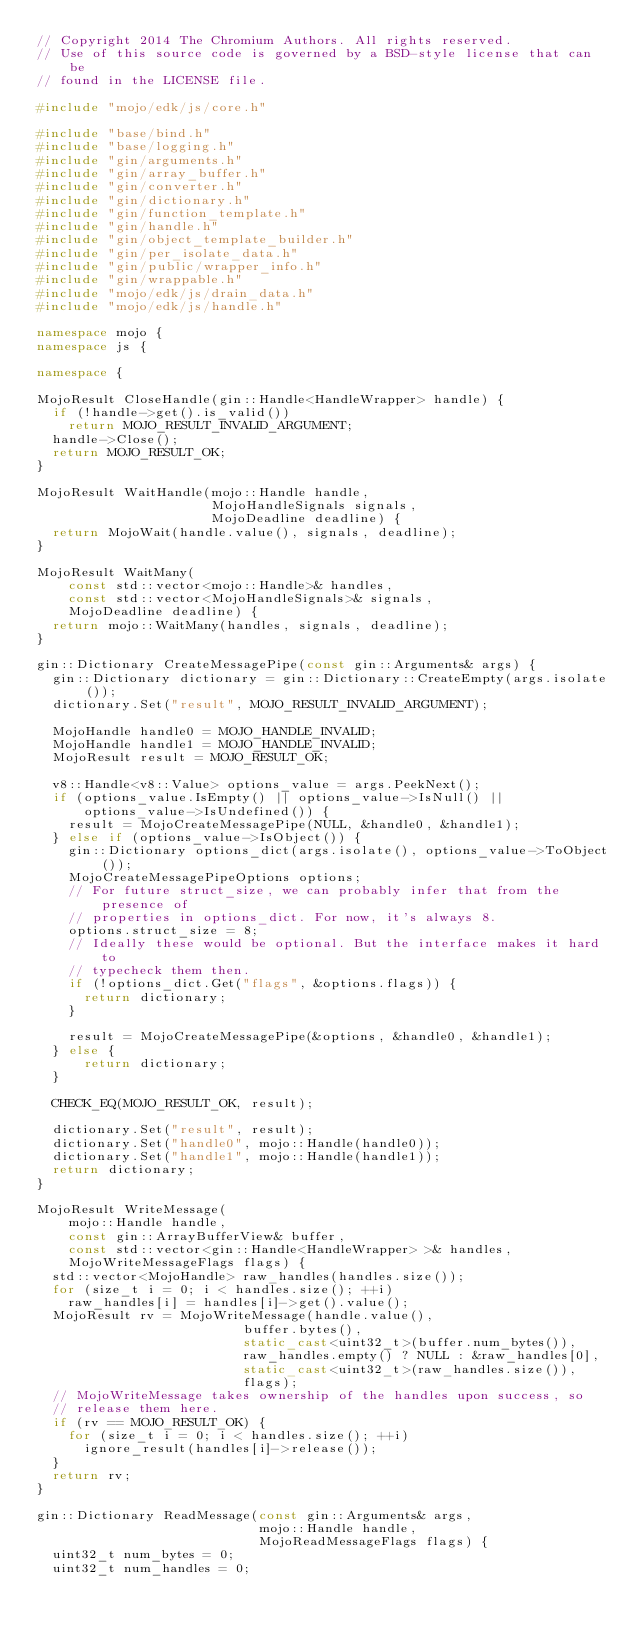<code> <loc_0><loc_0><loc_500><loc_500><_C++_>// Copyright 2014 The Chromium Authors. All rights reserved.
// Use of this source code is governed by a BSD-style license that can be
// found in the LICENSE file.

#include "mojo/edk/js/core.h"

#include "base/bind.h"
#include "base/logging.h"
#include "gin/arguments.h"
#include "gin/array_buffer.h"
#include "gin/converter.h"
#include "gin/dictionary.h"
#include "gin/function_template.h"
#include "gin/handle.h"
#include "gin/object_template_builder.h"
#include "gin/per_isolate_data.h"
#include "gin/public/wrapper_info.h"
#include "gin/wrappable.h"
#include "mojo/edk/js/drain_data.h"
#include "mojo/edk/js/handle.h"

namespace mojo {
namespace js {

namespace {

MojoResult CloseHandle(gin::Handle<HandleWrapper> handle) {
  if (!handle->get().is_valid())
    return MOJO_RESULT_INVALID_ARGUMENT;
  handle->Close();
  return MOJO_RESULT_OK;
}

MojoResult WaitHandle(mojo::Handle handle,
                      MojoHandleSignals signals,
                      MojoDeadline deadline) {
  return MojoWait(handle.value(), signals, deadline);
}

MojoResult WaitMany(
    const std::vector<mojo::Handle>& handles,
    const std::vector<MojoHandleSignals>& signals,
    MojoDeadline deadline) {
  return mojo::WaitMany(handles, signals, deadline);
}

gin::Dictionary CreateMessagePipe(const gin::Arguments& args) {
  gin::Dictionary dictionary = gin::Dictionary::CreateEmpty(args.isolate());
  dictionary.Set("result", MOJO_RESULT_INVALID_ARGUMENT);

  MojoHandle handle0 = MOJO_HANDLE_INVALID;
  MojoHandle handle1 = MOJO_HANDLE_INVALID;
  MojoResult result = MOJO_RESULT_OK;

  v8::Handle<v8::Value> options_value = args.PeekNext();
  if (options_value.IsEmpty() || options_value->IsNull() ||
      options_value->IsUndefined()) {
    result = MojoCreateMessagePipe(NULL, &handle0, &handle1);
  } else if (options_value->IsObject()) {
    gin::Dictionary options_dict(args.isolate(), options_value->ToObject());
    MojoCreateMessagePipeOptions options;
    // For future struct_size, we can probably infer that from the presence of
    // properties in options_dict. For now, it's always 8.
    options.struct_size = 8;
    // Ideally these would be optional. But the interface makes it hard to
    // typecheck them then.
    if (!options_dict.Get("flags", &options.flags)) {
      return dictionary;
    }

    result = MojoCreateMessagePipe(&options, &handle0, &handle1);
  } else {
      return dictionary;
  }

  CHECK_EQ(MOJO_RESULT_OK, result);

  dictionary.Set("result", result);
  dictionary.Set("handle0", mojo::Handle(handle0));
  dictionary.Set("handle1", mojo::Handle(handle1));
  return dictionary;
}

MojoResult WriteMessage(
    mojo::Handle handle,
    const gin::ArrayBufferView& buffer,
    const std::vector<gin::Handle<HandleWrapper> >& handles,
    MojoWriteMessageFlags flags) {
  std::vector<MojoHandle> raw_handles(handles.size());
  for (size_t i = 0; i < handles.size(); ++i)
    raw_handles[i] = handles[i]->get().value();
  MojoResult rv = MojoWriteMessage(handle.value(),
                          buffer.bytes(),
                          static_cast<uint32_t>(buffer.num_bytes()),
                          raw_handles.empty() ? NULL : &raw_handles[0],
                          static_cast<uint32_t>(raw_handles.size()),
                          flags);
  // MojoWriteMessage takes ownership of the handles upon success, so
  // release them here.
  if (rv == MOJO_RESULT_OK) {
    for (size_t i = 0; i < handles.size(); ++i)
      ignore_result(handles[i]->release());
  }
  return rv;
}

gin::Dictionary ReadMessage(const gin::Arguments& args,
                            mojo::Handle handle,
                            MojoReadMessageFlags flags) {
  uint32_t num_bytes = 0;
  uint32_t num_handles = 0;</code> 